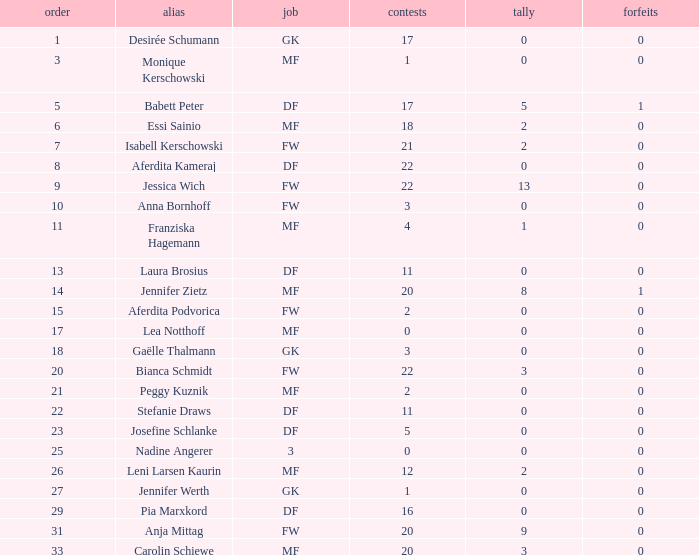What is the average goals for Essi Sainio? 2.0. 